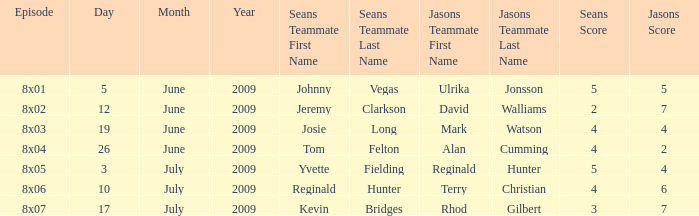Who was on Jason's team in the episode where Sean's team was Reginald D. Hunter and Kelly Osbourne? Terry Christian and Isy Suttie. 